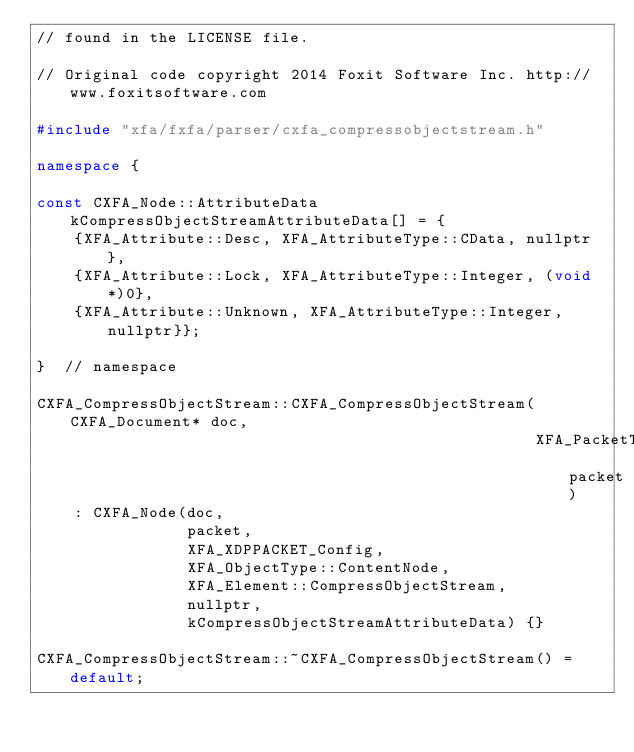<code> <loc_0><loc_0><loc_500><loc_500><_C++_>// found in the LICENSE file.

// Original code copyright 2014 Foxit Software Inc. http://www.foxitsoftware.com

#include "xfa/fxfa/parser/cxfa_compressobjectstream.h"

namespace {

const CXFA_Node::AttributeData kCompressObjectStreamAttributeData[] = {
    {XFA_Attribute::Desc, XFA_AttributeType::CData, nullptr},
    {XFA_Attribute::Lock, XFA_AttributeType::Integer, (void*)0},
    {XFA_Attribute::Unknown, XFA_AttributeType::Integer, nullptr}};

}  // namespace

CXFA_CompressObjectStream::CXFA_CompressObjectStream(CXFA_Document* doc,
                                                     XFA_PacketType packet)
    : CXFA_Node(doc,
                packet,
                XFA_XDPPACKET_Config,
                XFA_ObjectType::ContentNode,
                XFA_Element::CompressObjectStream,
                nullptr,
                kCompressObjectStreamAttributeData) {}

CXFA_CompressObjectStream::~CXFA_CompressObjectStream() = default;
</code> 